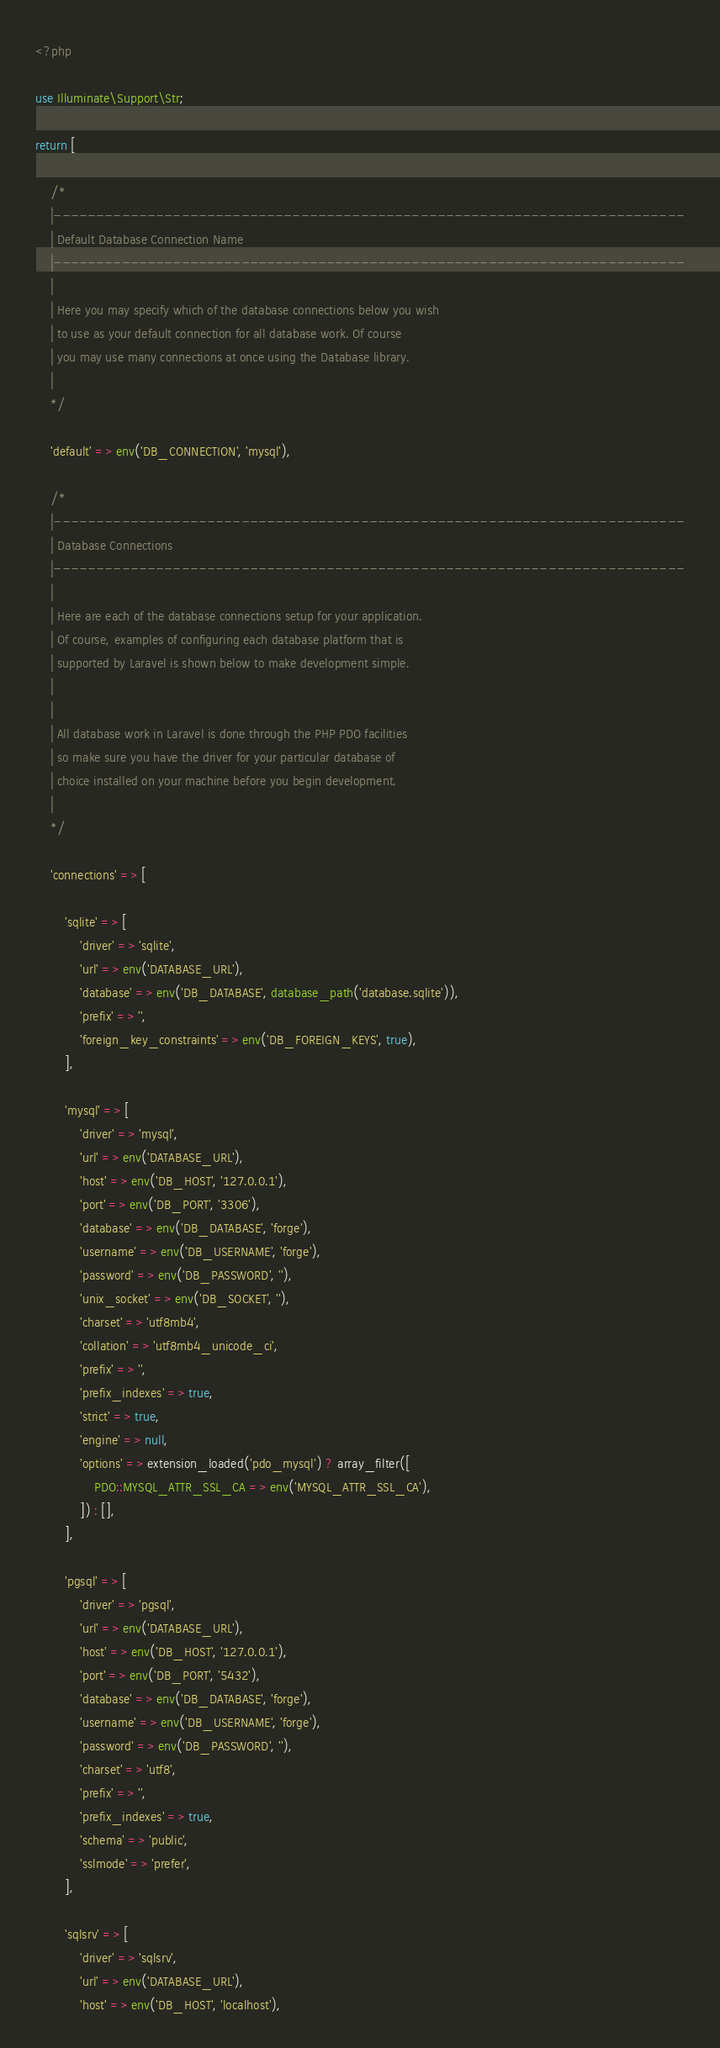Convert code to text. <code><loc_0><loc_0><loc_500><loc_500><_PHP_><?php

use Illuminate\Support\Str;

return [

    /*
    |--------------------------------------------------------------------------
    | Default Database Connection Name
    |--------------------------------------------------------------------------
    |
    | Here you may specify which of the database connections below you wish
    | to use as your default connection for all database work. Of course
    | you may use many connections at once using the Database library.
    |
    */

    'default' => env('DB_CONNECTION', 'mysql'),

    /*
    |--------------------------------------------------------------------------
    | Database Connections
    |--------------------------------------------------------------------------
    |
    | Here are each of the database connections setup for your application.
    | Of course, examples of configuring each database platform that is
    | supported by Laravel is shown below to make development simple.
    |
    |
    | All database work in Laravel is done through the PHP PDO facilities
    | so make sure you have the driver for your particular database of
    | choice installed on your machine before you begin development.
    |
    */

    'connections' => [

        'sqlite' => [
            'driver' => 'sqlite',
            'url' => env('DATABASE_URL'),
            'database' => env('DB_DATABASE', database_path('database.sqlite')),
            'prefix' => '',
            'foreign_key_constraints' => env('DB_FOREIGN_KEYS', true),
        ],

        'mysql' => [
            'driver' => 'mysql',
            'url' => env('DATABASE_URL'),
            'host' => env('DB_HOST', '127.0.0.1'),
            'port' => env('DB_PORT', '3306'),
            'database' => env('DB_DATABASE', 'forge'),
            'username' => env('DB_USERNAME', 'forge'),
            'password' => env('DB_PASSWORD', ''),
            'unix_socket' => env('DB_SOCKET', ''),
            'charset' => 'utf8mb4',
            'collation' => 'utf8mb4_unicode_ci',
            'prefix' => '',
            'prefix_indexes' => true,
            'strict' => true,
            'engine' => null,
            'options' => extension_loaded('pdo_mysql') ? array_filter([
                PDO::MYSQL_ATTR_SSL_CA => env('MYSQL_ATTR_SSL_CA'),
            ]) : [],
        ],

        'pgsql' => [
            'driver' => 'pgsql',
            'url' => env('DATABASE_URL'),
            'host' => env('DB_HOST', '127.0.0.1'),
            'port' => env('DB_PORT', '5432'),
            'database' => env('DB_DATABASE', 'forge'),
            'username' => env('DB_USERNAME', 'forge'),
            'password' => env('DB_PASSWORD', ''),
            'charset' => 'utf8',
            'prefix' => '',
            'prefix_indexes' => true,
            'schema' => 'public',
            'sslmode' => 'prefer',
        ],

        'sqlsrv' => [
            'driver' => 'sqlsrv',
            'url' => env('DATABASE_URL'),
            'host' => env('DB_HOST', 'localhost'),</code> 